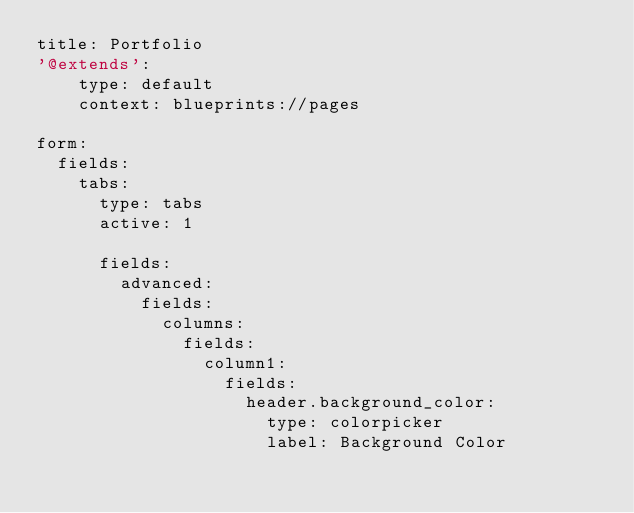Convert code to text. <code><loc_0><loc_0><loc_500><loc_500><_YAML_>title: Portfolio
'@extends':
    type: default
    context: blueprints://pages

form:
  fields:
    tabs:
      type: tabs
      active: 1

      fields:
        advanced:
          fields:
            columns:
              fields:
                column1:
                  fields:
                    header.background_color:
                      type: colorpicker
                      label: Background Color</code> 